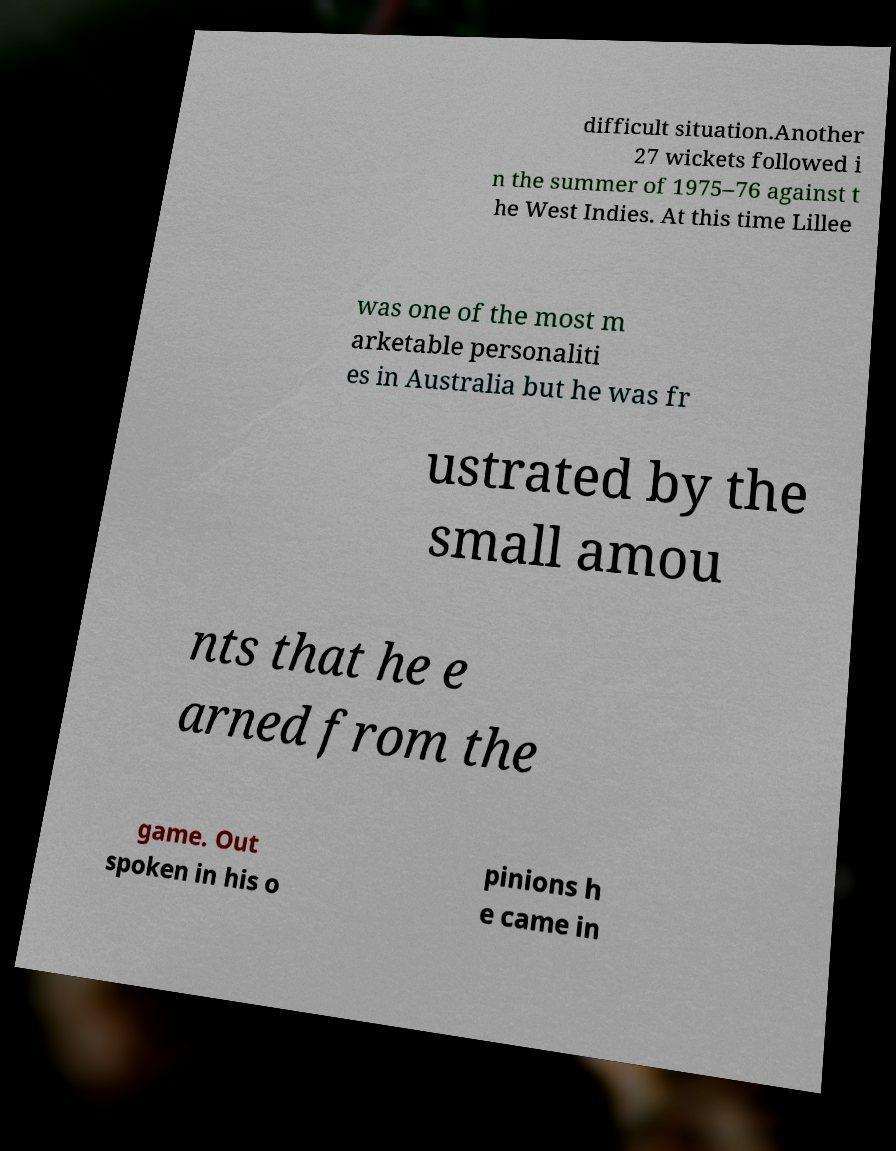There's text embedded in this image that I need extracted. Can you transcribe it verbatim? difficult situation.Another 27 wickets followed i n the summer of 1975–76 against t he West Indies. At this time Lillee was one of the most m arketable personaliti es in Australia but he was fr ustrated by the small amou nts that he e arned from the game. Out spoken in his o pinions h e came in 